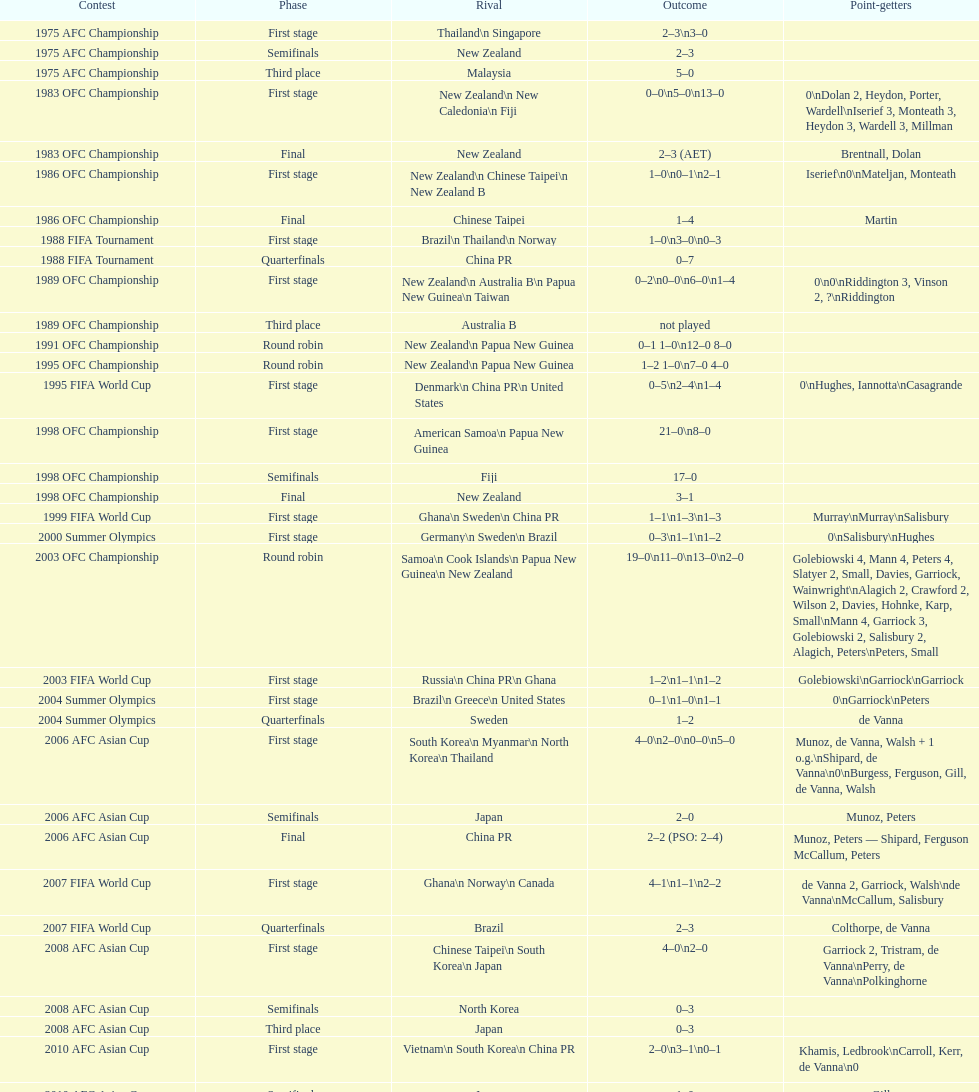How many players scored during the 1983 ofc championship competition? 9. 